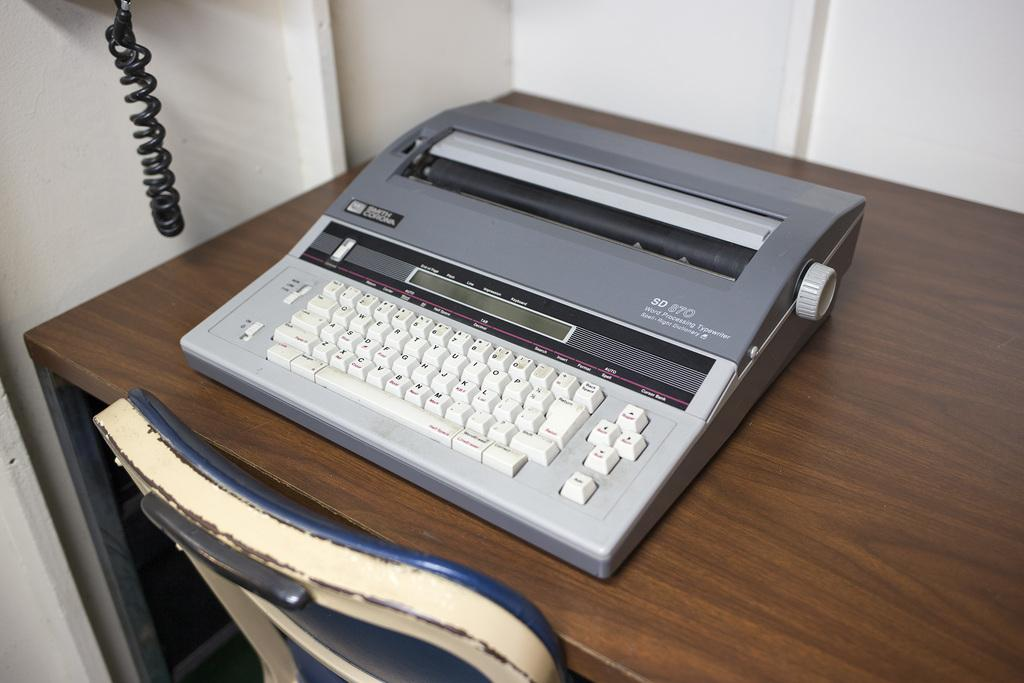<image>
Create a compact narrative representing the image presented. a typewriter that has the letter K on it 